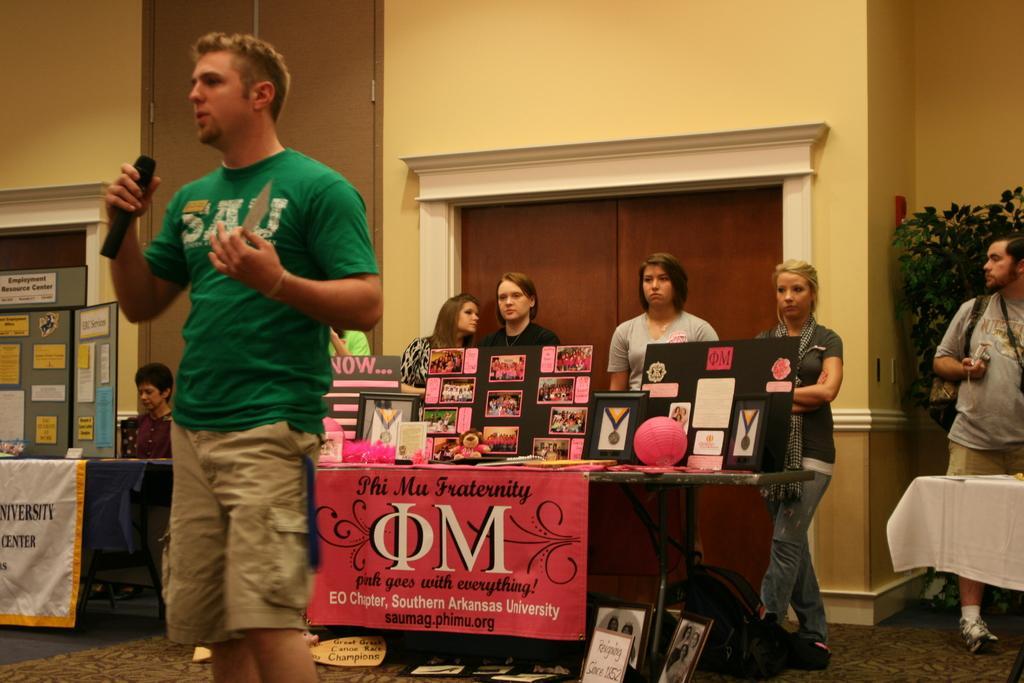Could you give a brief overview of what you see in this image? This is the man standing and holding the mike. I can see the tables. These are the boards, lantern, mirror, teddy bear and few other things on it. These are the banners hanging to the tables. I can see photo frames and a bag, which are placed on the floor. There are few people standing and a person sitting. This looks like a wooden door. Here is another table, which is covered with white cloth. I think this is a houseplant. This looks like a board with papers attached to it. 